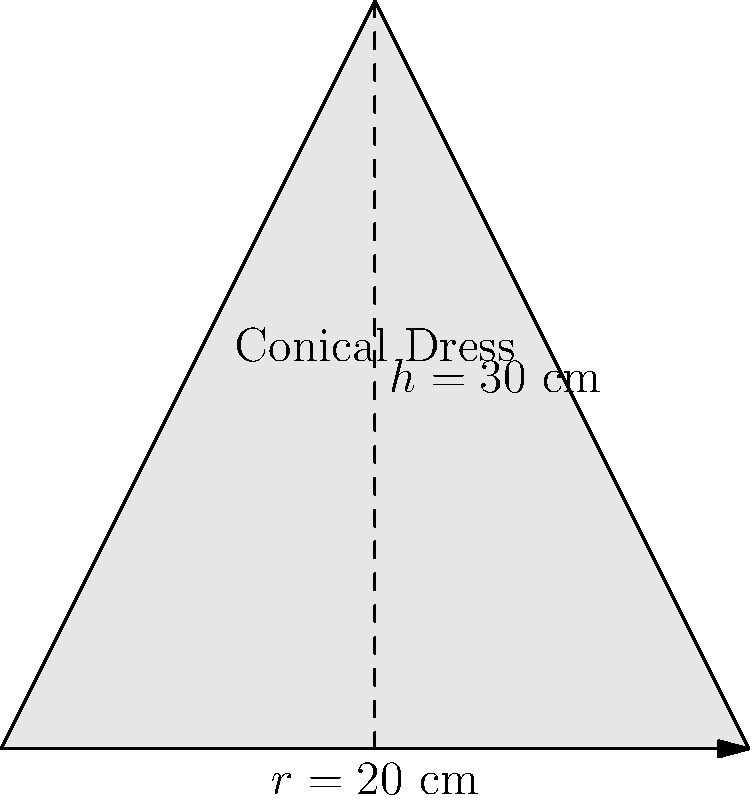As a fashion designer who has collaborated with Rita Ora on her iconic red carpet outfits, you're tasked with creating a stunning conical dress for her next appearance. The dress has a height of 30 cm and a base radius of 20 cm. Calculate the surface area of the fabric needed for this conical dress, excluding the circular base. Round your answer to the nearest square centimeter. To calculate the surface area of a conical dress (excluding the base), we need to use the formula for the lateral surface area of a cone:

$$A = \pi r s$$

Where:
$A$ = lateral surface area
$r$ = radius of the base
$s$ = slant height of the cone

We're given:
$h = 30$ cm (height)
$r = 20$ cm (radius)

Step 1: Calculate the slant height ($s$) using the Pythagorean theorem:
$$s^2 = r^2 + h^2$$
$$s^2 = 20^2 + 30^2 = 400 + 900 = 1300$$
$$s = \sqrt{1300} \approx 36.06$ cm

Step 2: Apply the formula for lateral surface area:
$$A = \pi r s$$
$$A = \pi \cdot 20 \cdot 36.06$$
$$A \approx 2265.66$ cm²

Step 3: Round to the nearest square centimeter:
$$A \approx 2266$ cm²
Answer: 2266 cm² 